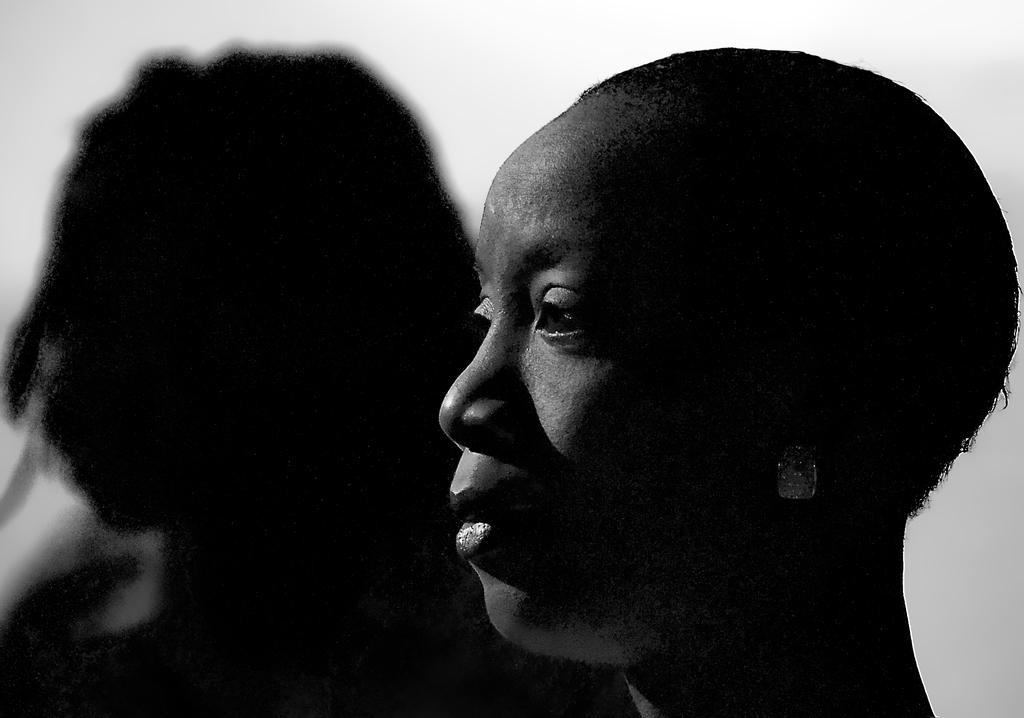What is the main subject of the image? The main subject of the image is a person's face. What can be observed about the color of the person's face in the image? The person's face is black in color. Can you see a swing in the background of the image? There is no swing present in the image; it only features a person's face. What type of border is surrounding the person's face in the image? The image does not show any borders surrounding the person's face. 